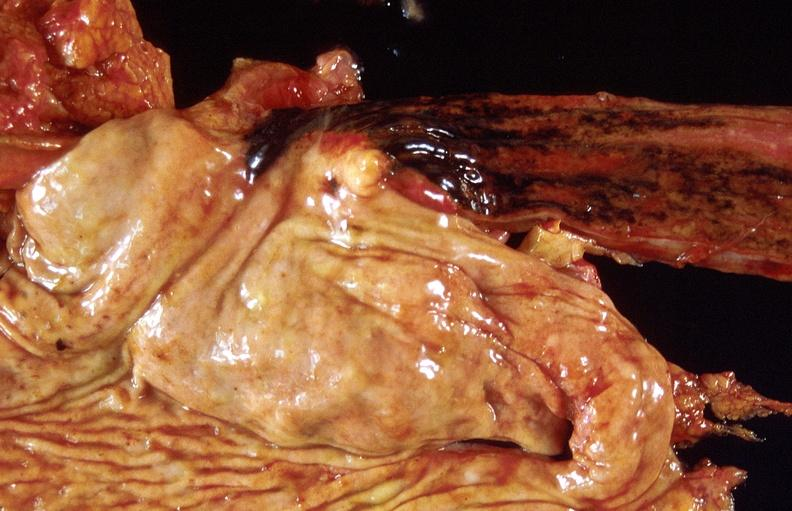s gastrointestinal present?
Answer the question using a single word or phrase. Yes 